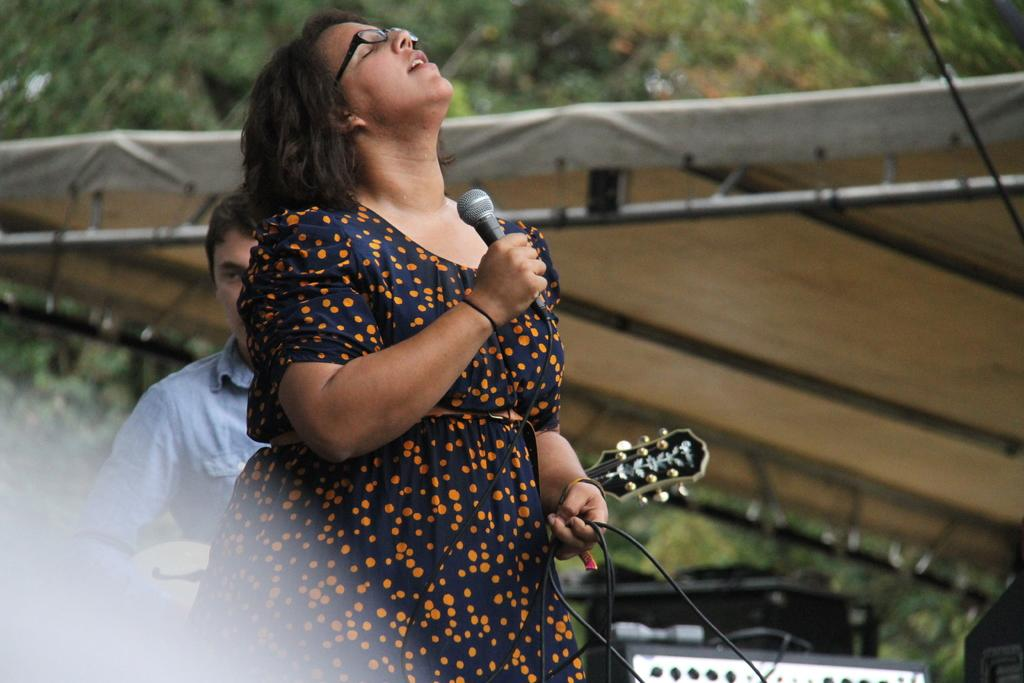What is the woman holding in the image? The woman is holding a mic. Can you describe the woman's appearance? The woman is wearing spectacles. What is the person next to the woman doing? There is a person playing a guitar. Where is the scene taking place? The setting is a tent. What can be seen in the background of the image? There are trees in the distance. What objects might be used for recording or amplifying sound? There are devices present. How many ducks are present in the image? There are no ducks present in the image. What type of cave is visible in the image? There is no cave visible in the image. 